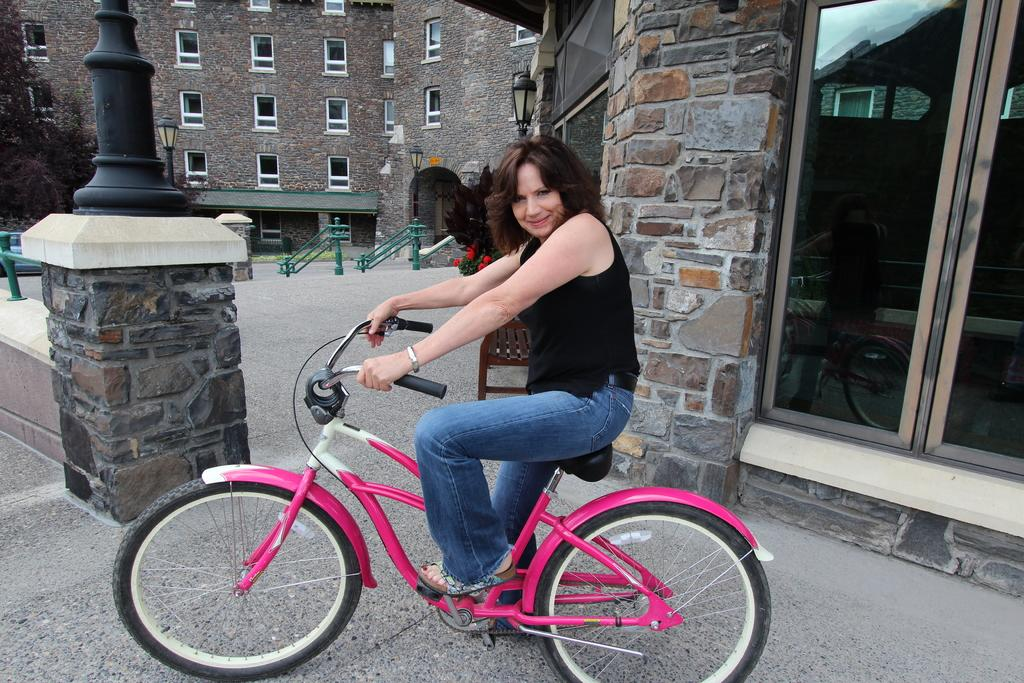Who is the main subject in the image? There is a woman in the image. What is the woman doing in the image? The woman is riding a bicycle. What can be seen in the background of the image? There is a building, windows, a pole, and a glass door visible in the background. Can you see a rabbit playing with a zipper near the coil in the image? No, there is no rabbit, zipper, or coil present in the image. 